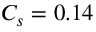<formula> <loc_0><loc_0><loc_500><loc_500>C _ { s } = 0 . 1 4</formula> 